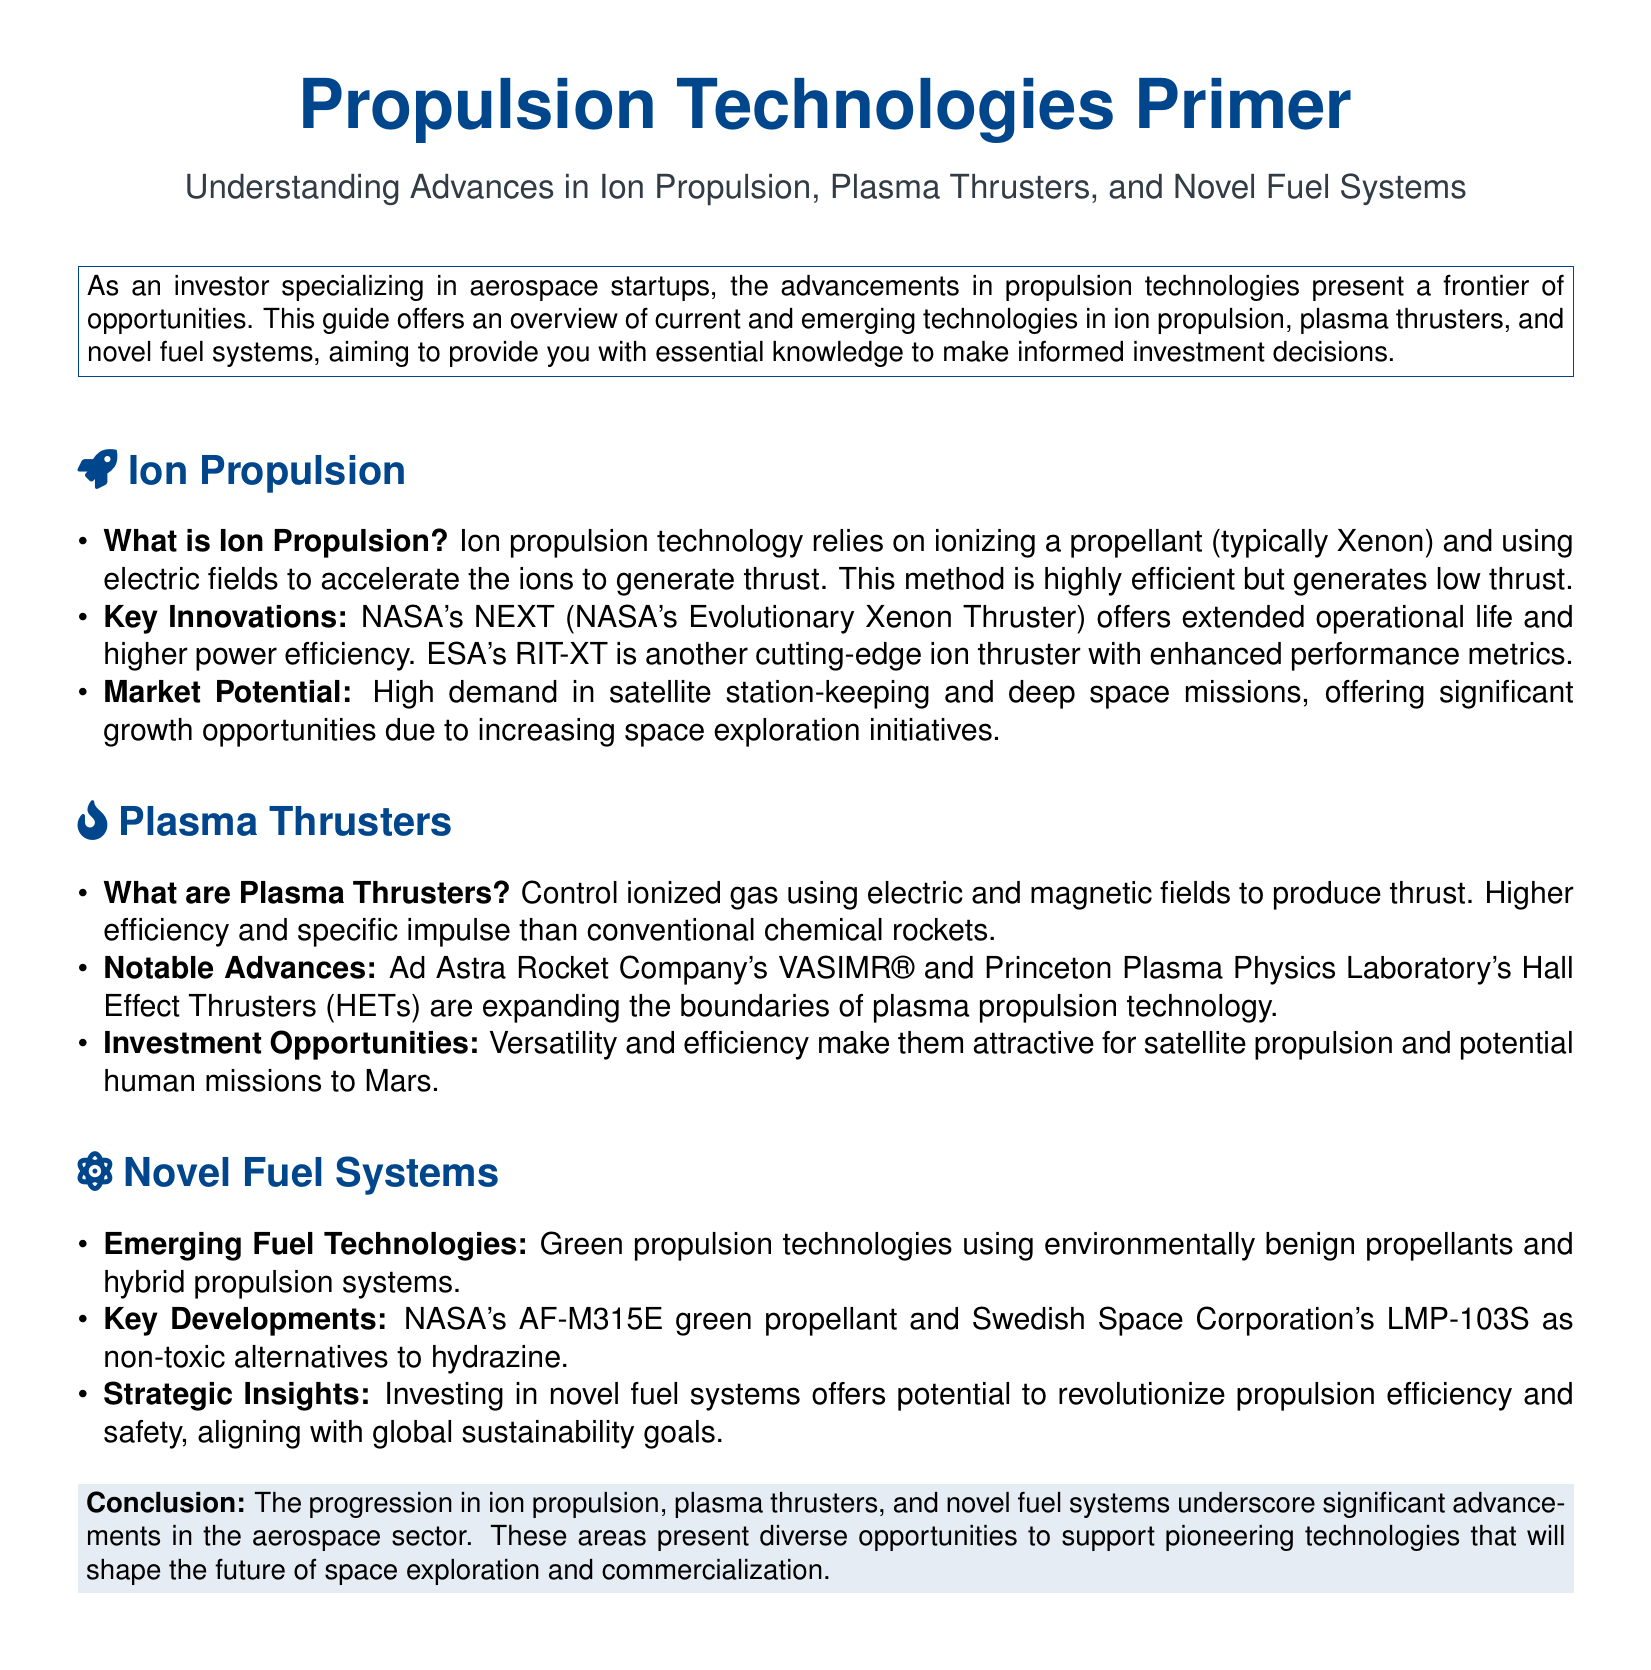What is ion propulsion technology? Ion propulsion technology relies on ionizing a propellant (typically Xenon) and using electric fields to accelerate the ions to generate thrust.
Answer: Ionizing a propellant and using electric fields What does NEXT stand for? NEXT refers to NASA's Evolutionary Xenon Thruster, which is a key innovation in ion propulsion.
Answer: NASA's Evolutionary Xenon Thruster What type of thrust generation do plasma thrusters utilize? Plasma thrusters control ionized gas using electric and magnetic fields to produce thrust.
Answer: Electric and magnetic fields Which company developed the VASIMR® plasma thruster? Ad Astra Rocket Company developed the VASIMR® plasma thruster, contributing notable advances in plasma propulsion technology.
Answer: Ad Astra Rocket Company What is a key feature of NASA's AF-M315E green propellant? NASA's AF-M315E is highlighted as a green propellant and as one of the non-toxic alternatives to hydrazine.
Answer: Green propellant What is one investment opportunity presented by plasma thrusters? The document mentions versatility and efficiency, making plasma thrusters attractive for satellite propulsion and potential human missions.
Answer: Satellite propulsion and potential human missions What advantage do novel fuel systems offer? Investing in novel fuel systems offers the potential to revolutionize propulsion efficiency and safety.
Answer: Revolutionize propulsion efficiency and safety Which propellant is used in ion propulsion? The typical propellant used in ion propulsion technology is Xenon.
Answer: Xenon What are the potential uses for advancements in ion propulsion technologies? The advancements in ion propulsion have high demand in satellite station-keeping and deep space missions.
Answer: Satellite station-keeping and deep space missions 